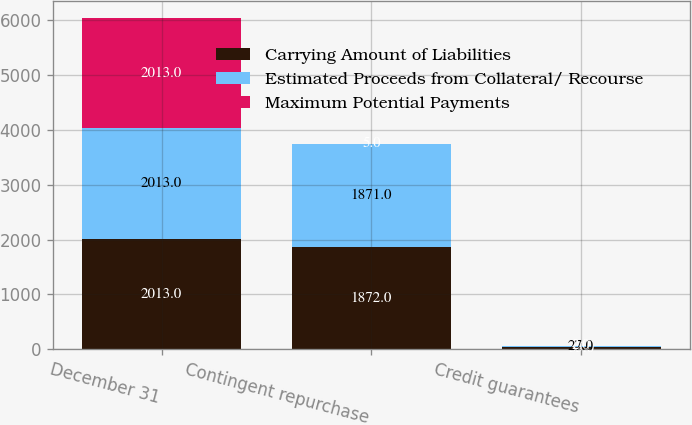<chart> <loc_0><loc_0><loc_500><loc_500><stacked_bar_chart><ecel><fcel>December 31<fcel>Contingent repurchase<fcel>Credit guarantees<nl><fcel>Carrying Amount of Liabilities<fcel>2013<fcel>1872<fcel>35<nl><fcel>Estimated Proceeds from Collateral/ Recourse<fcel>2013<fcel>1871<fcel>27<nl><fcel>Maximum Potential Payments<fcel>2013<fcel>5<fcel>2<nl></chart> 